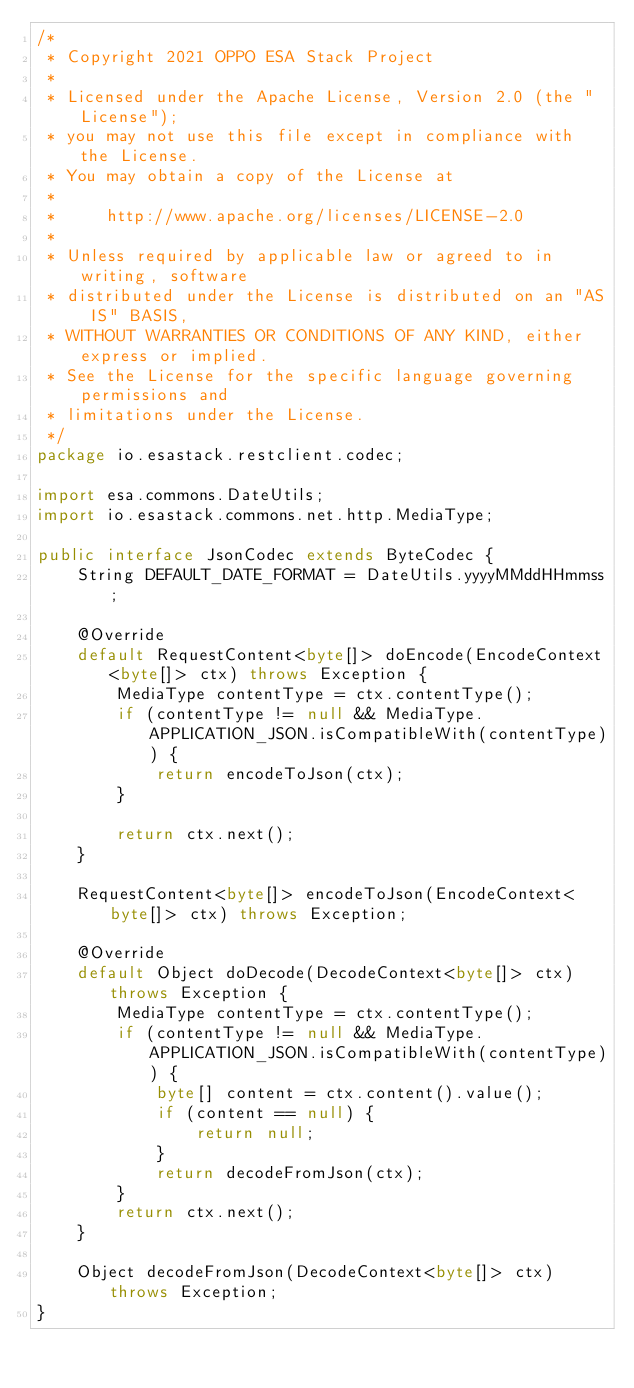<code> <loc_0><loc_0><loc_500><loc_500><_Java_>/*
 * Copyright 2021 OPPO ESA Stack Project
 *
 * Licensed under the Apache License, Version 2.0 (the "License");
 * you may not use this file except in compliance with the License.
 * You may obtain a copy of the License at
 *
 *     http://www.apache.org/licenses/LICENSE-2.0
 *
 * Unless required by applicable law or agreed to in writing, software
 * distributed under the License is distributed on an "AS IS" BASIS,
 * WITHOUT WARRANTIES OR CONDITIONS OF ANY KIND, either express or implied.
 * See the License for the specific language governing permissions and
 * limitations under the License.
 */
package io.esastack.restclient.codec;

import esa.commons.DateUtils;
import io.esastack.commons.net.http.MediaType;

public interface JsonCodec extends ByteCodec {
    String DEFAULT_DATE_FORMAT = DateUtils.yyyyMMddHHmmss;

    @Override
    default RequestContent<byte[]> doEncode(EncodeContext<byte[]> ctx) throws Exception {
        MediaType contentType = ctx.contentType();
        if (contentType != null && MediaType.APPLICATION_JSON.isCompatibleWith(contentType)) {
            return encodeToJson(ctx);
        }

        return ctx.next();
    }

    RequestContent<byte[]> encodeToJson(EncodeContext<byte[]> ctx) throws Exception;

    @Override
    default Object doDecode(DecodeContext<byte[]> ctx) throws Exception {
        MediaType contentType = ctx.contentType();
        if (contentType != null && MediaType.APPLICATION_JSON.isCompatibleWith(contentType)) {
            byte[] content = ctx.content().value();
            if (content == null) {
                return null;
            }
            return decodeFromJson(ctx);
        }
        return ctx.next();
    }

    Object decodeFromJson(DecodeContext<byte[]> ctx) throws Exception;
}
</code> 